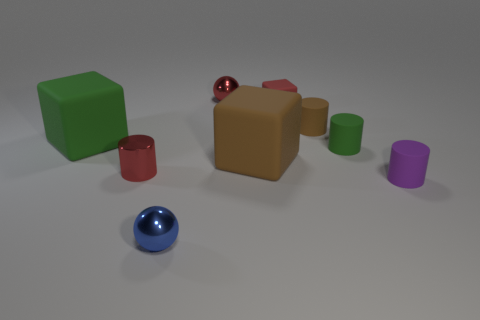Do the shiny cylinder and the tiny rubber cube have the same color?
Ensure brevity in your answer.  Yes. What color is the other small metallic object that is the same shape as the small purple thing?
Give a very brief answer. Red. There is a tiny thing that is left of the small blue metallic object; is it the same color as the tiny cube?
Make the answer very short. Yes. Are there any small cylinders behind the small purple matte thing?
Your answer should be compact. Yes. What is the color of the tiny cylinder that is in front of the brown cylinder and to the left of the tiny green rubber object?
Give a very brief answer. Red. There is a rubber thing that is the same color as the small shiny cylinder; what shape is it?
Offer a terse response. Cube. There is a matte block that is left of the large cube that is to the right of the metallic cylinder; how big is it?
Your response must be concise. Large. What number of spheres are either red metallic objects or large green things?
Ensure brevity in your answer.  1. There is a cube that is the same size as the red shiny sphere; what is its color?
Your answer should be very brief. Red. What is the shape of the green thing that is on the right side of the rubber object behind the brown cylinder?
Provide a short and direct response. Cylinder. 